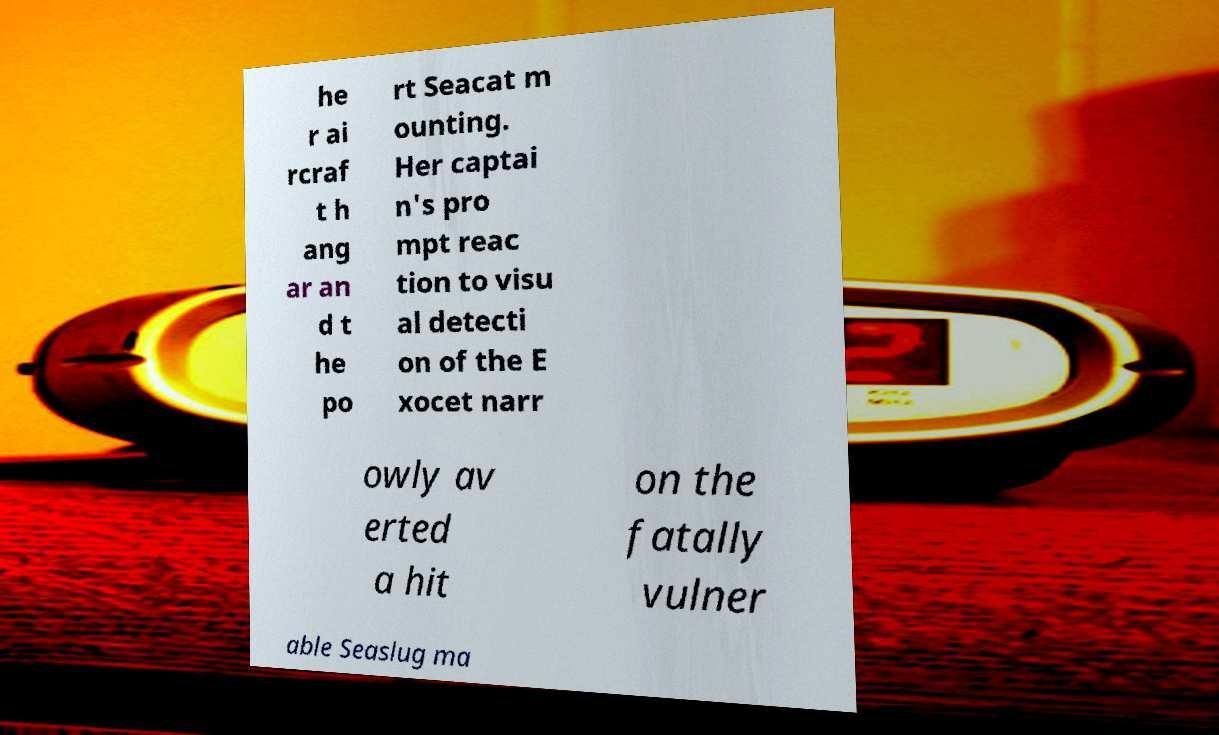Please identify and transcribe the text found in this image. he r ai rcraf t h ang ar an d t he po rt Seacat m ounting. Her captai n's pro mpt reac tion to visu al detecti on of the E xocet narr owly av erted a hit on the fatally vulner able Seaslug ma 